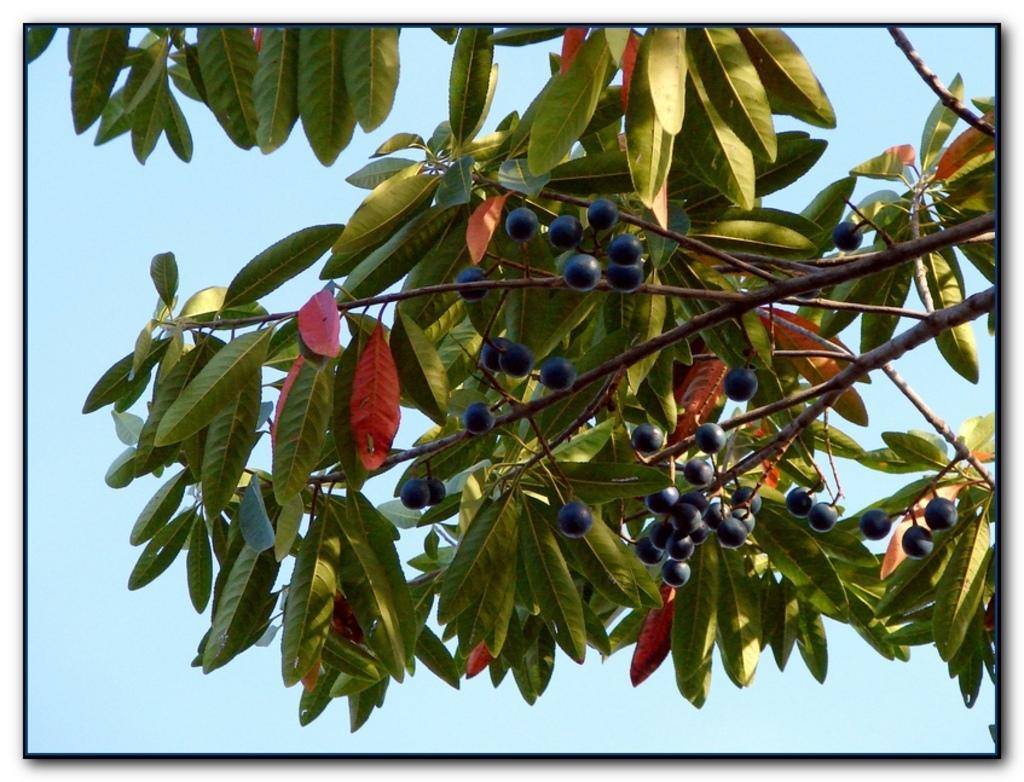What type of plant can be seen in the image? There is a tree in the image. What is present on the tree? There are fruits in the image. What can be seen in the background of the image? The sky is visible in the background of the image. Where is the goat located in the image? There is no goat present in the image. 